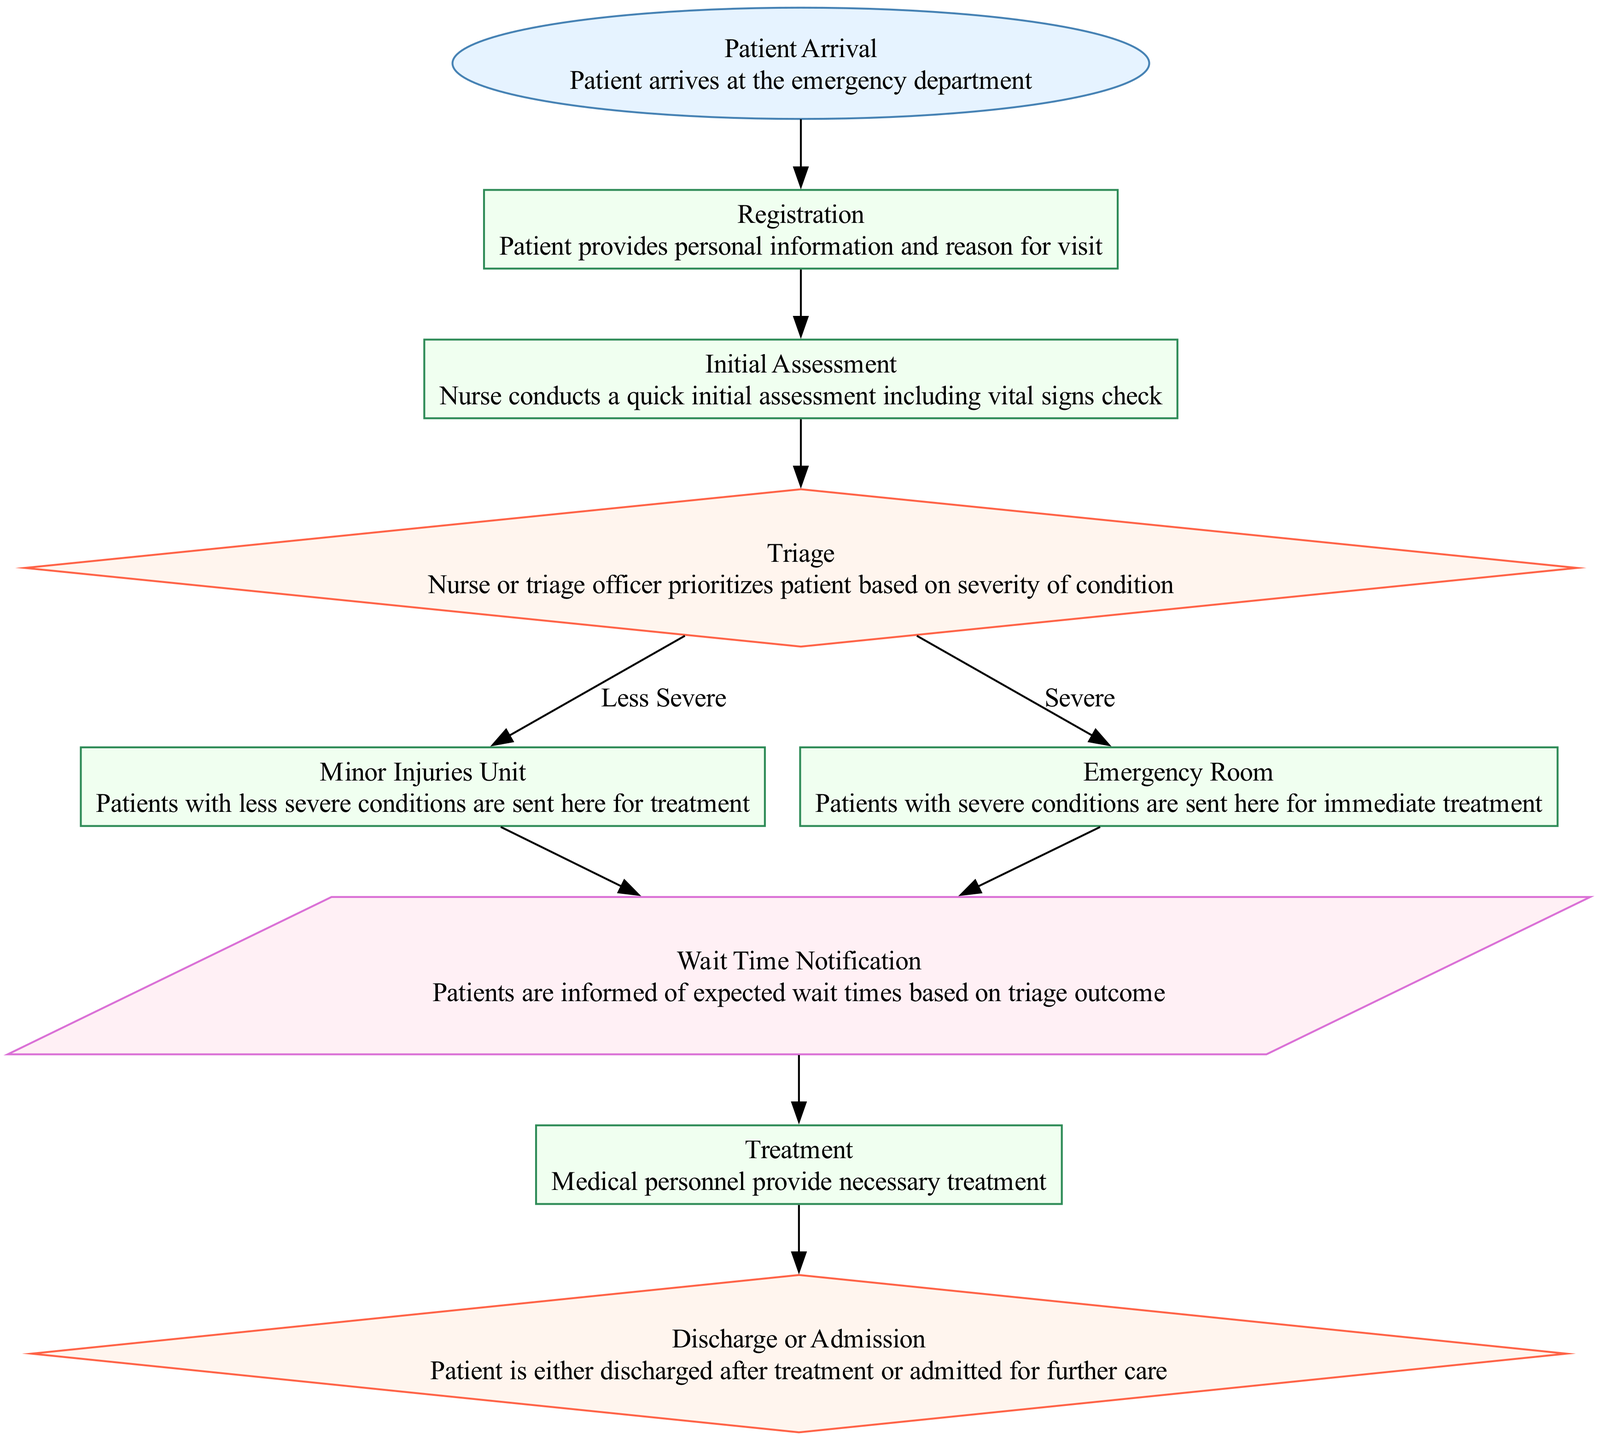What is the first step in the process flow? The first step, represented in the diagram, is "Patient Arrival", indicating that the process starts when a patient arrives at the emergency department.
Answer: Patient Arrival How many processes are there in the diagram? By analyzing the diagram, we can count the processes indicated by rectangles. There are five processes total: Registration, Initial Assessment, Minor Injuries Unit, Emergency Room, and Treatment.
Answer: Five What happens to patients with severe conditions? Patients with severe conditions proceed from the Triage node to the Emergency Room for immediate treatment, as indicated by the flow direction in the diagram.
Answer: Emergency Room Which node provides information about expected wait times? The "Wait Time Notification" node specifically informs patients about the expected wait times based on the outcomes from the Triage step in the process.
Answer: Wait Time Notification What decision follows the Treatment process? After the Treatment process, the diagram indicates that patients face a decision regarding whether they will be discharged or admitted for further care, represented by the "Discharge or Admission" node.
Answer: Discharge or Admission What is the outcome for patients with less severe conditions? Patients classified as having less severe conditions are directed from the Triage node to the Minor Injuries Unit for treatment, as shown in the diagram flow.
Answer: Minor Injuries Unit How are the nodes connected in the diagram? The connections between the nodes indicate the flow of the process: arrows point from Patient Arrival to Registration, then from each step through to the decision points and outputs, illustrating the entire intake and triage process.
Answer: Through arrows What type of diagram is used to represent this flow? This representation is specifically a Block Diagram, which is structured to illustrate the sequence and relationship of processes, decisions, and outputs visually.
Answer: Block Diagram 